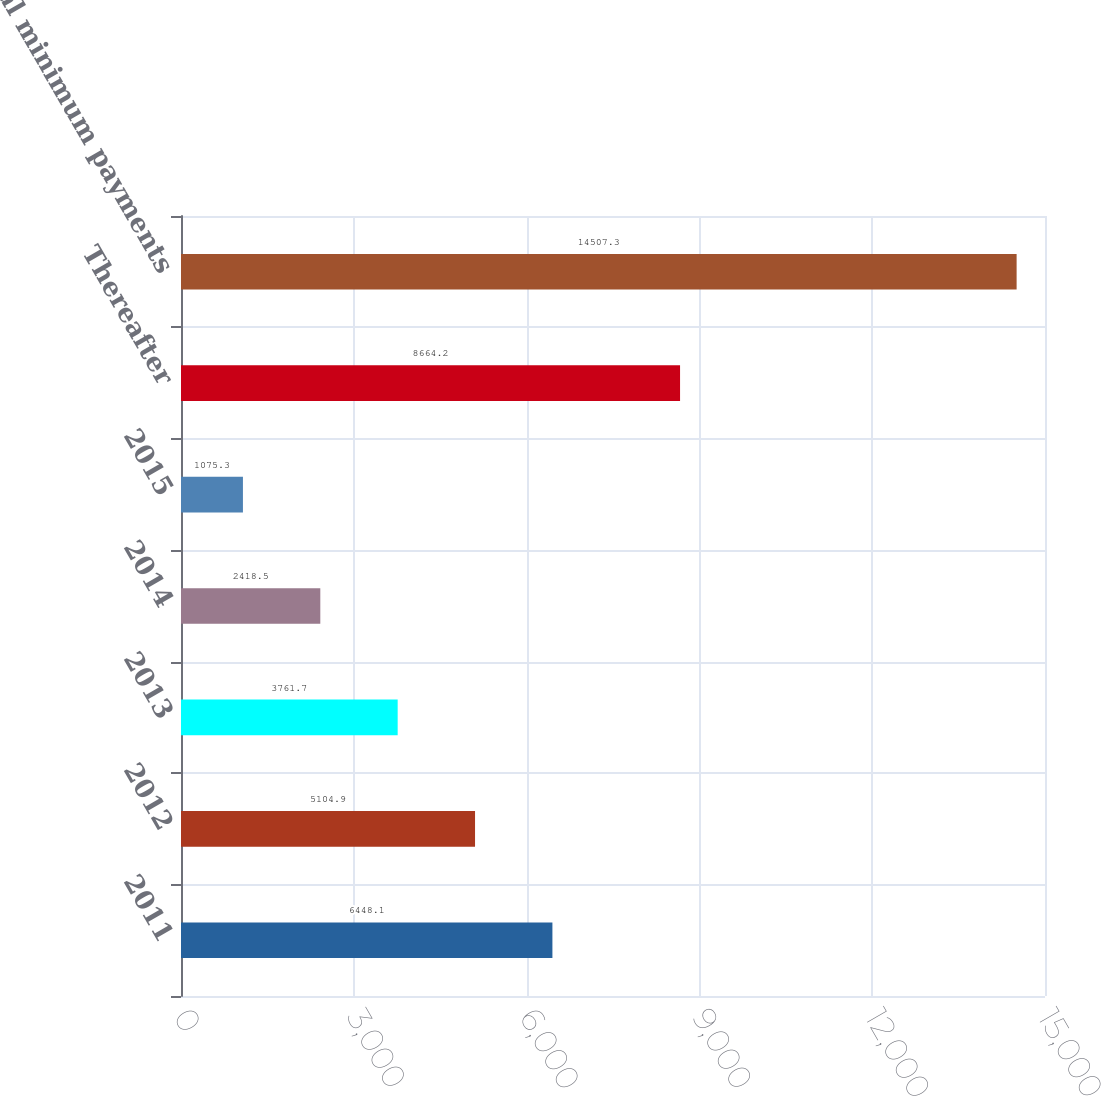Convert chart to OTSL. <chart><loc_0><loc_0><loc_500><loc_500><bar_chart><fcel>2011<fcel>2012<fcel>2013<fcel>2014<fcel>2015<fcel>Thereafter<fcel>Total minimum payments<nl><fcel>6448.1<fcel>5104.9<fcel>3761.7<fcel>2418.5<fcel>1075.3<fcel>8664.2<fcel>14507.3<nl></chart> 